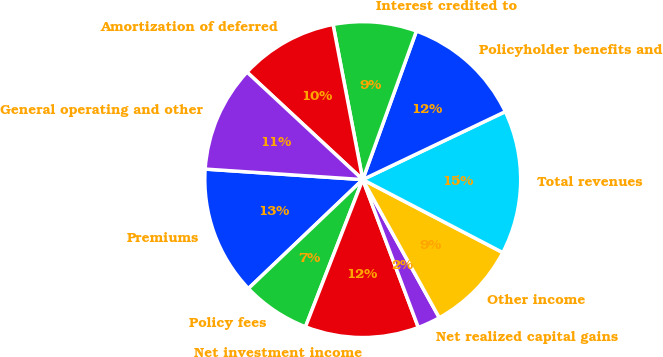<chart> <loc_0><loc_0><loc_500><loc_500><pie_chart><fcel>Premiums<fcel>Policy fees<fcel>Net investment income<fcel>Net realized capital gains<fcel>Other income<fcel>Total revenues<fcel>Policyholder benefits and<fcel>Interest credited to<fcel>Amortization of deferred<fcel>General operating and other<nl><fcel>13.18%<fcel>6.98%<fcel>11.63%<fcel>2.33%<fcel>9.3%<fcel>14.73%<fcel>12.4%<fcel>8.53%<fcel>10.08%<fcel>10.85%<nl></chart> 